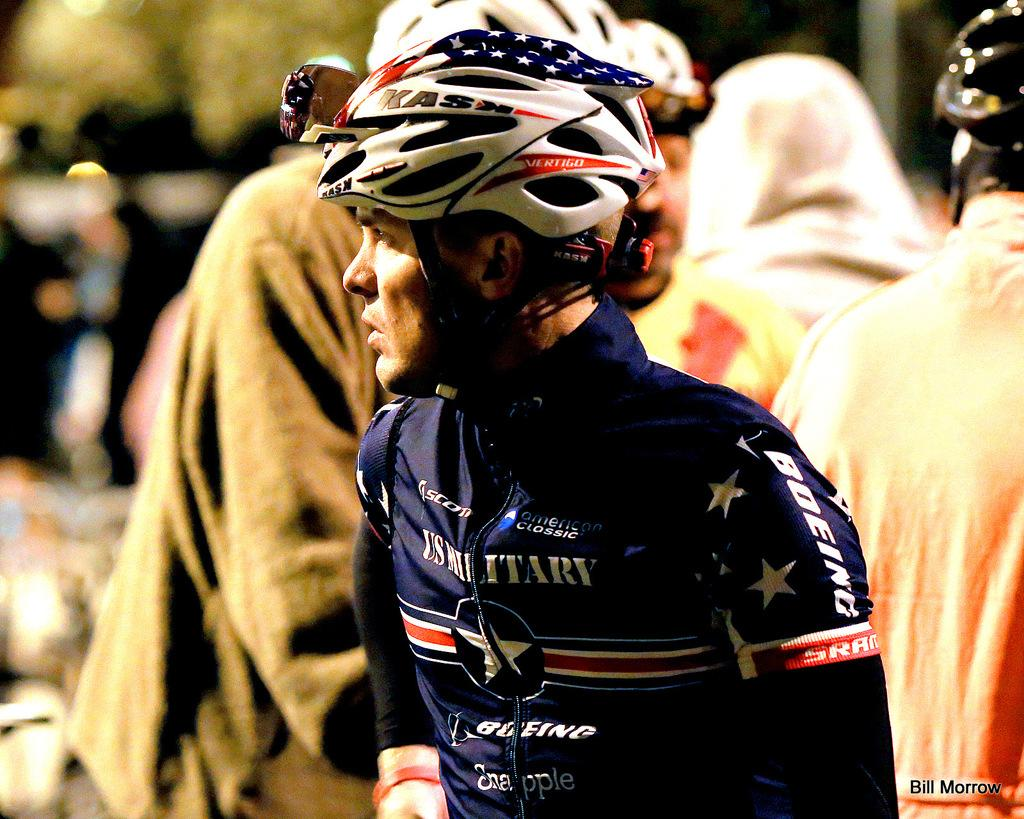How many people can be seen in the image? There are many people in the image. Can you describe the man in the foreground? The man in the foreground is standing, wearing a helmet, and a sports suit. What is the condition of the background in the image? The background of the image is blurry. What type of texture can be seen on the man's eyes in the image? There is no mention of the man's eyes in the provided facts, and therefore no texture can be observed on them. 